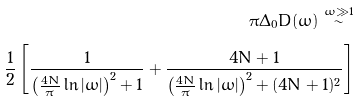<formula> <loc_0><loc_0><loc_500><loc_500>\pi \Delta _ { 0 } D ( \omega ) \overset { \bar { \omega } \gg 1 } \sim \\ \frac { 1 } { 2 } \left [ \frac { 1 } { \left ( \frac { 4 N } { \pi } \ln | \bar { \omega } | \right ) ^ { 2 } + 1 } + \frac { 4 N + 1 } { \left ( \frac { 4 N } { \pi } \ln | \bar { \omega } | \right ) ^ { 2 } + ( 4 N + 1 ) ^ { 2 } } \right ]</formula> 